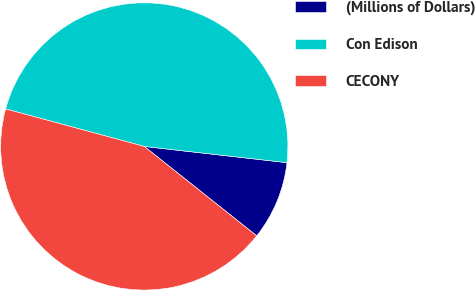<chart> <loc_0><loc_0><loc_500><loc_500><pie_chart><fcel>(Millions of Dollars)<fcel>Con Edison<fcel>CECONY<nl><fcel>8.89%<fcel>47.59%<fcel>43.51%<nl></chart> 